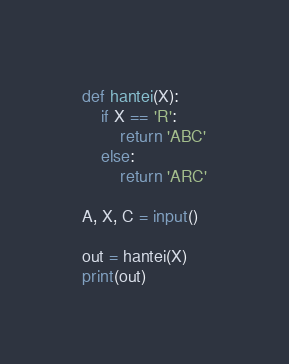Convert code to text. <code><loc_0><loc_0><loc_500><loc_500><_Python_>def hantei(X):
    if X == 'R':
        return 'ABC'
    else:
        return 'ARC'
      
A, X, C = input()

out = hantei(X)
print(out)</code> 